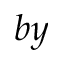Convert formula to latex. <formula><loc_0><loc_0><loc_500><loc_500>b y</formula> 